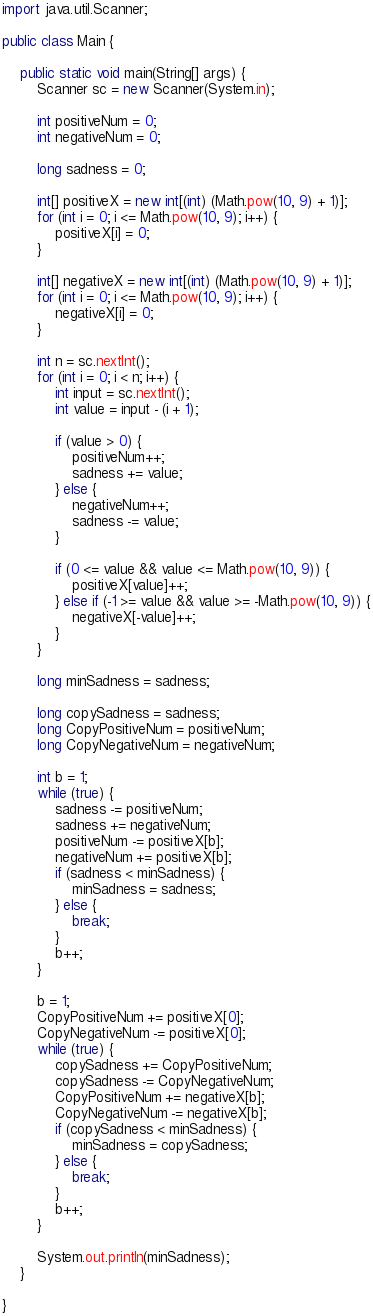<code> <loc_0><loc_0><loc_500><loc_500><_Java_>import java.util.Scanner;

public class Main {

	public static void main(String[] args) {
		Scanner sc = new Scanner(System.in);

		int positiveNum = 0;
		int negativeNum = 0;

		long sadness = 0;

		int[] positiveX = new int[(int) (Math.pow(10, 9) + 1)];
		for (int i = 0; i <= Math.pow(10, 9); i++) {
			positiveX[i] = 0;
		}

		int[] negativeX = new int[(int) (Math.pow(10, 9) + 1)];
		for (int i = 0; i <= Math.pow(10, 9); i++) {
			negativeX[i] = 0;
		}

		int n = sc.nextInt();
		for (int i = 0; i < n; i++) {
			int input = sc.nextInt();
			int value = input - (i + 1);

			if (value > 0) {
				positiveNum++;
				sadness += value;
			} else {
				negativeNum++;
				sadness -= value;
			}

			if (0 <= value && value <= Math.pow(10, 9)) {
				positiveX[value]++;
			} else if (-1 >= value && value >= -Math.pow(10, 9)) {
				negativeX[-value]++;
			}
		}

		long minSadness = sadness;

		long copySadness = sadness;
		long CopyPositiveNum = positiveNum;
		long CopyNegativeNum = negativeNum;

		int b = 1;
		while (true) {
			sadness -= positiveNum;
			sadness += negativeNum;
			positiveNum -= positiveX[b];
			negativeNum += positiveX[b];
			if (sadness < minSadness) {
				minSadness = sadness;
			} else {
				break;
			}
			b++;
		}

		b = 1;
		CopyPositiveNum += positiveX[0];
		CopyNegativeNum -= positiveX[0];
		while (true) {
			copySadness += CopyPositiveNum;
			copySadness -= CopyNegativeNum;
			CopyPositiveNum += negativeX[b];
			CopyNegativeNum -= negativeX[b];
			if (copySadness < minSadness) {
				minSadness = copySadness;
			} else {
				break;
			}
			b++;
		}

		System.out.println(minSadness);
	}

}
</code> 